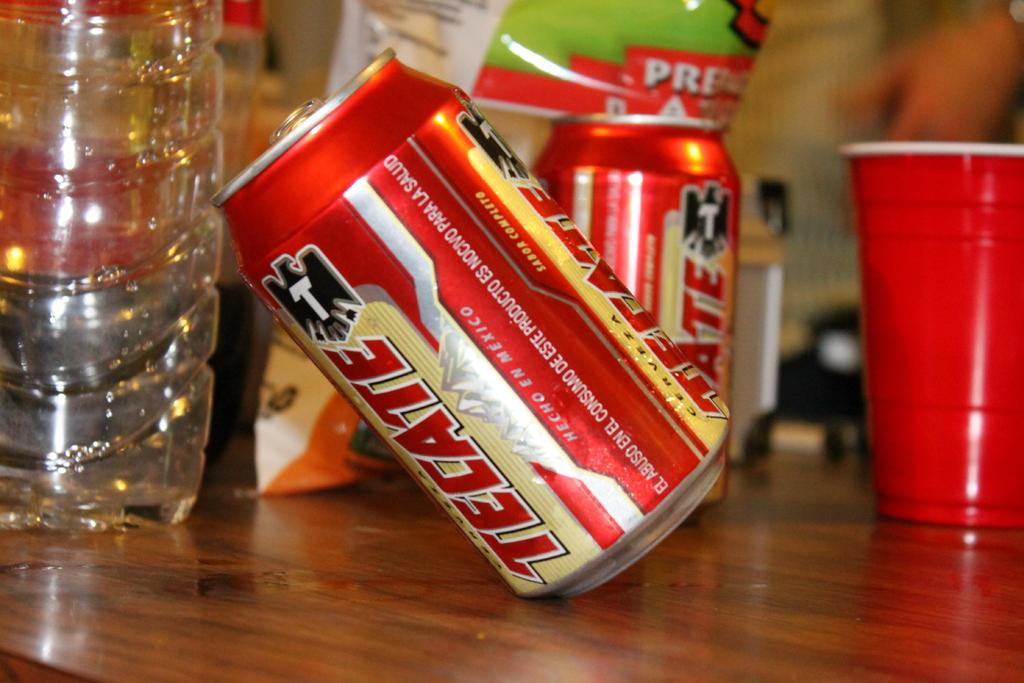<image>
Present a compact description of the photo's key features. Some cans of soda in red, the word Hecho is visible. 